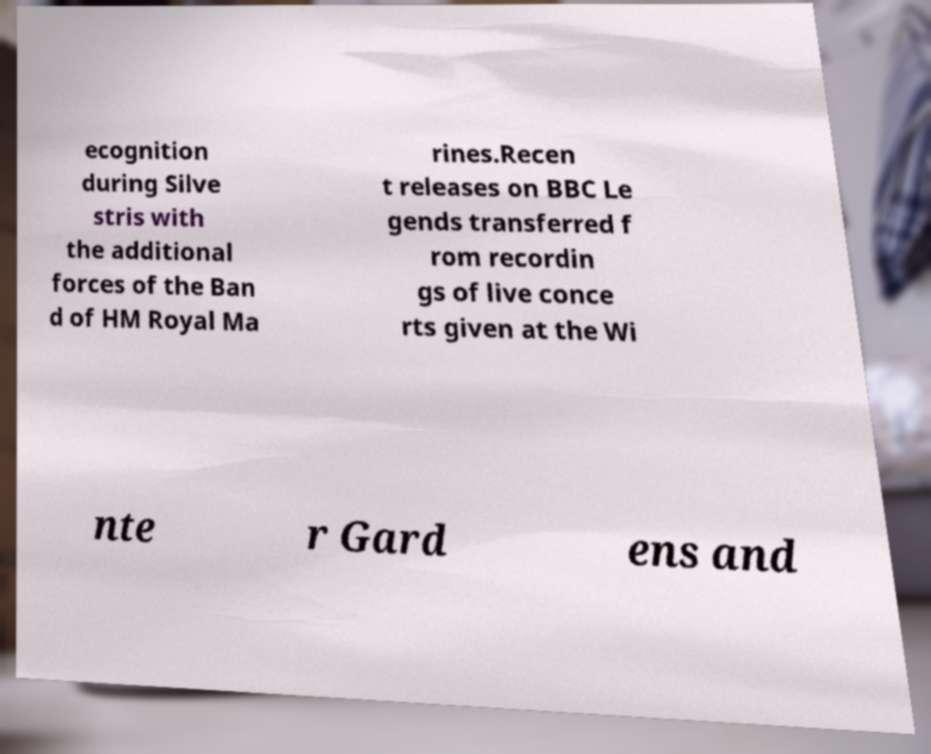Could you assist in decoding the text presented in this image and type it out clearly? ecognition during Silve stris with the additional forces of the Ban d of HM Royal Ma rines.Recen t releases on BBC Le gends transferred f rom recordin gs of live conce rts given at the Wi nte r Gard ens and 